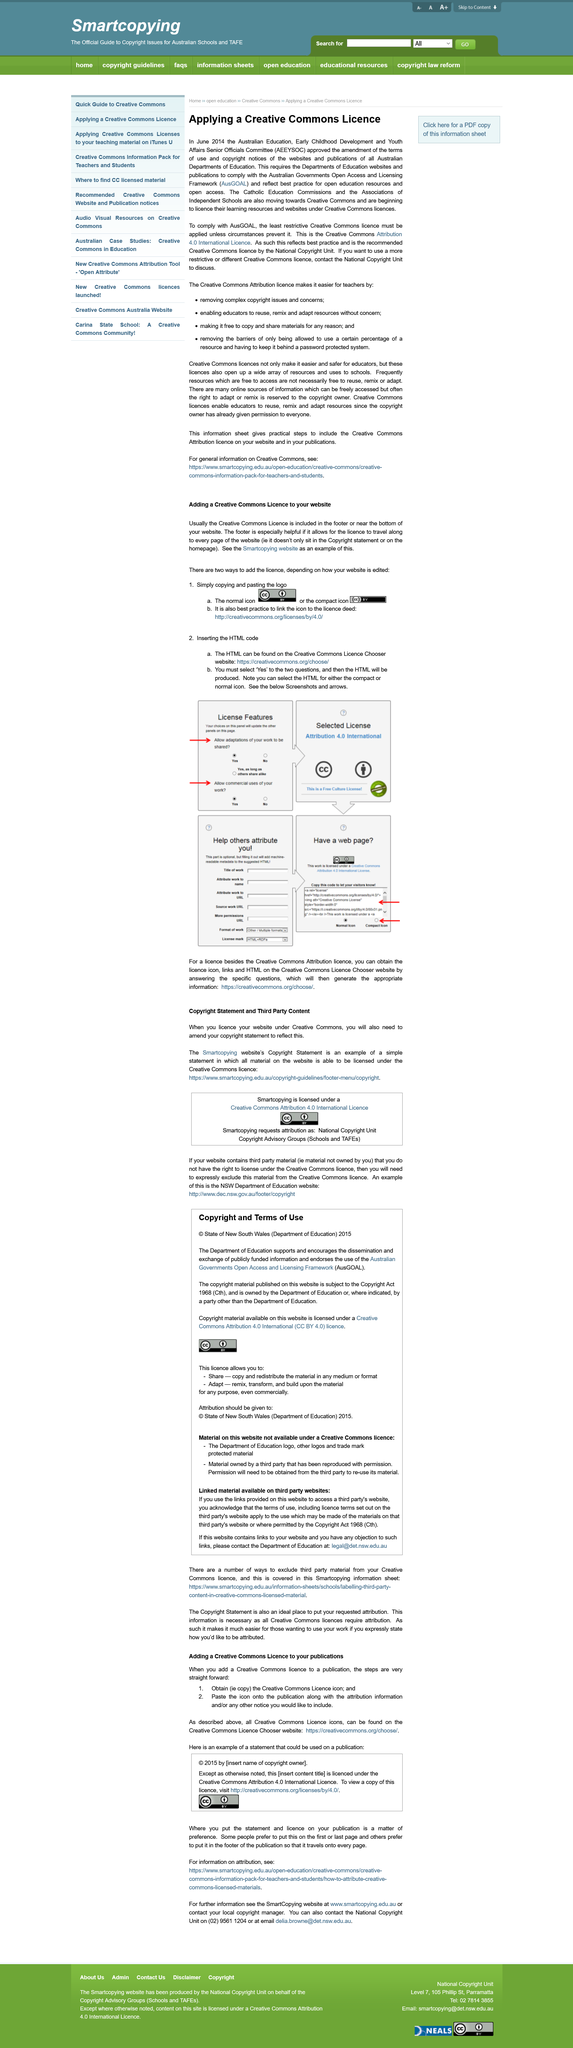Give some essential details in this illustration. The material on this website that is not available under a Creative Commons Licence includes the Department of Education Logo, other logos, and trademark protected material. The reproduction of material owned by a third party has been done with permission. If you have objections to links to your own website on a departmental website, you may contact the Department of Education at legal@det.nsw.edu.au for resolution. There are two steps involved in adding a Creative Commons license to your publication. To obtain a Creative Commons license, the first step is to obtain the license icon. AusGOAL is an abbreviation of the Australian Governments Open Access and Licensing Framework. 